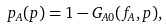Convert formula to latex. <formula><loc_0><loc_0><loc_500><loc_500>p _ { A } ( p ) = 1 - G _ { A 0 } ( f _ { A } , p ) ,</formula> 